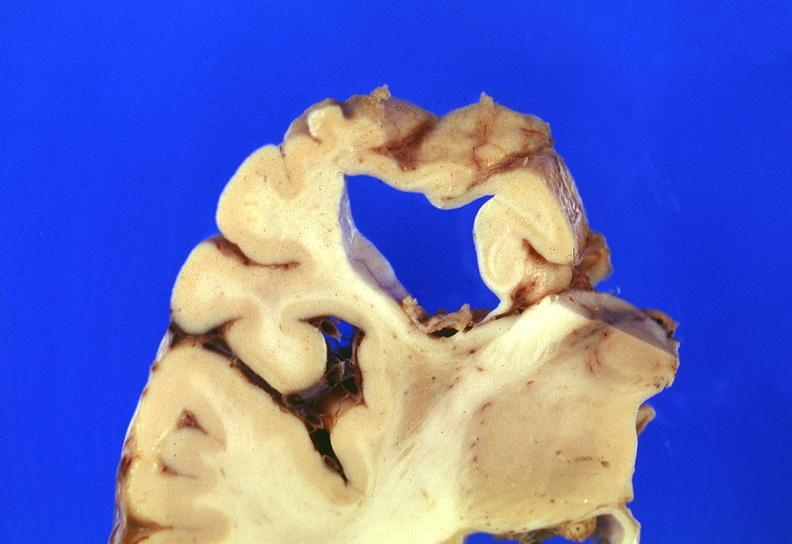what is present?
Answer the question using a single word or phrase. Nervous 